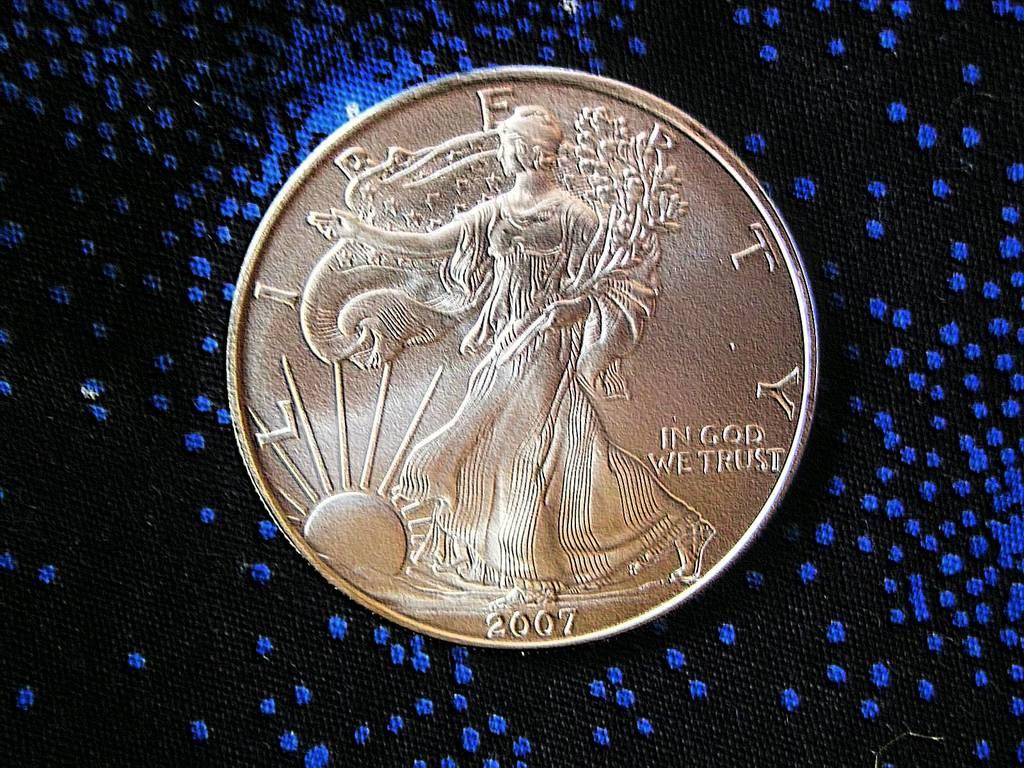Provide a one-sentence caption for the provided image. A golden coin from 2007 says "in gold we trust". 